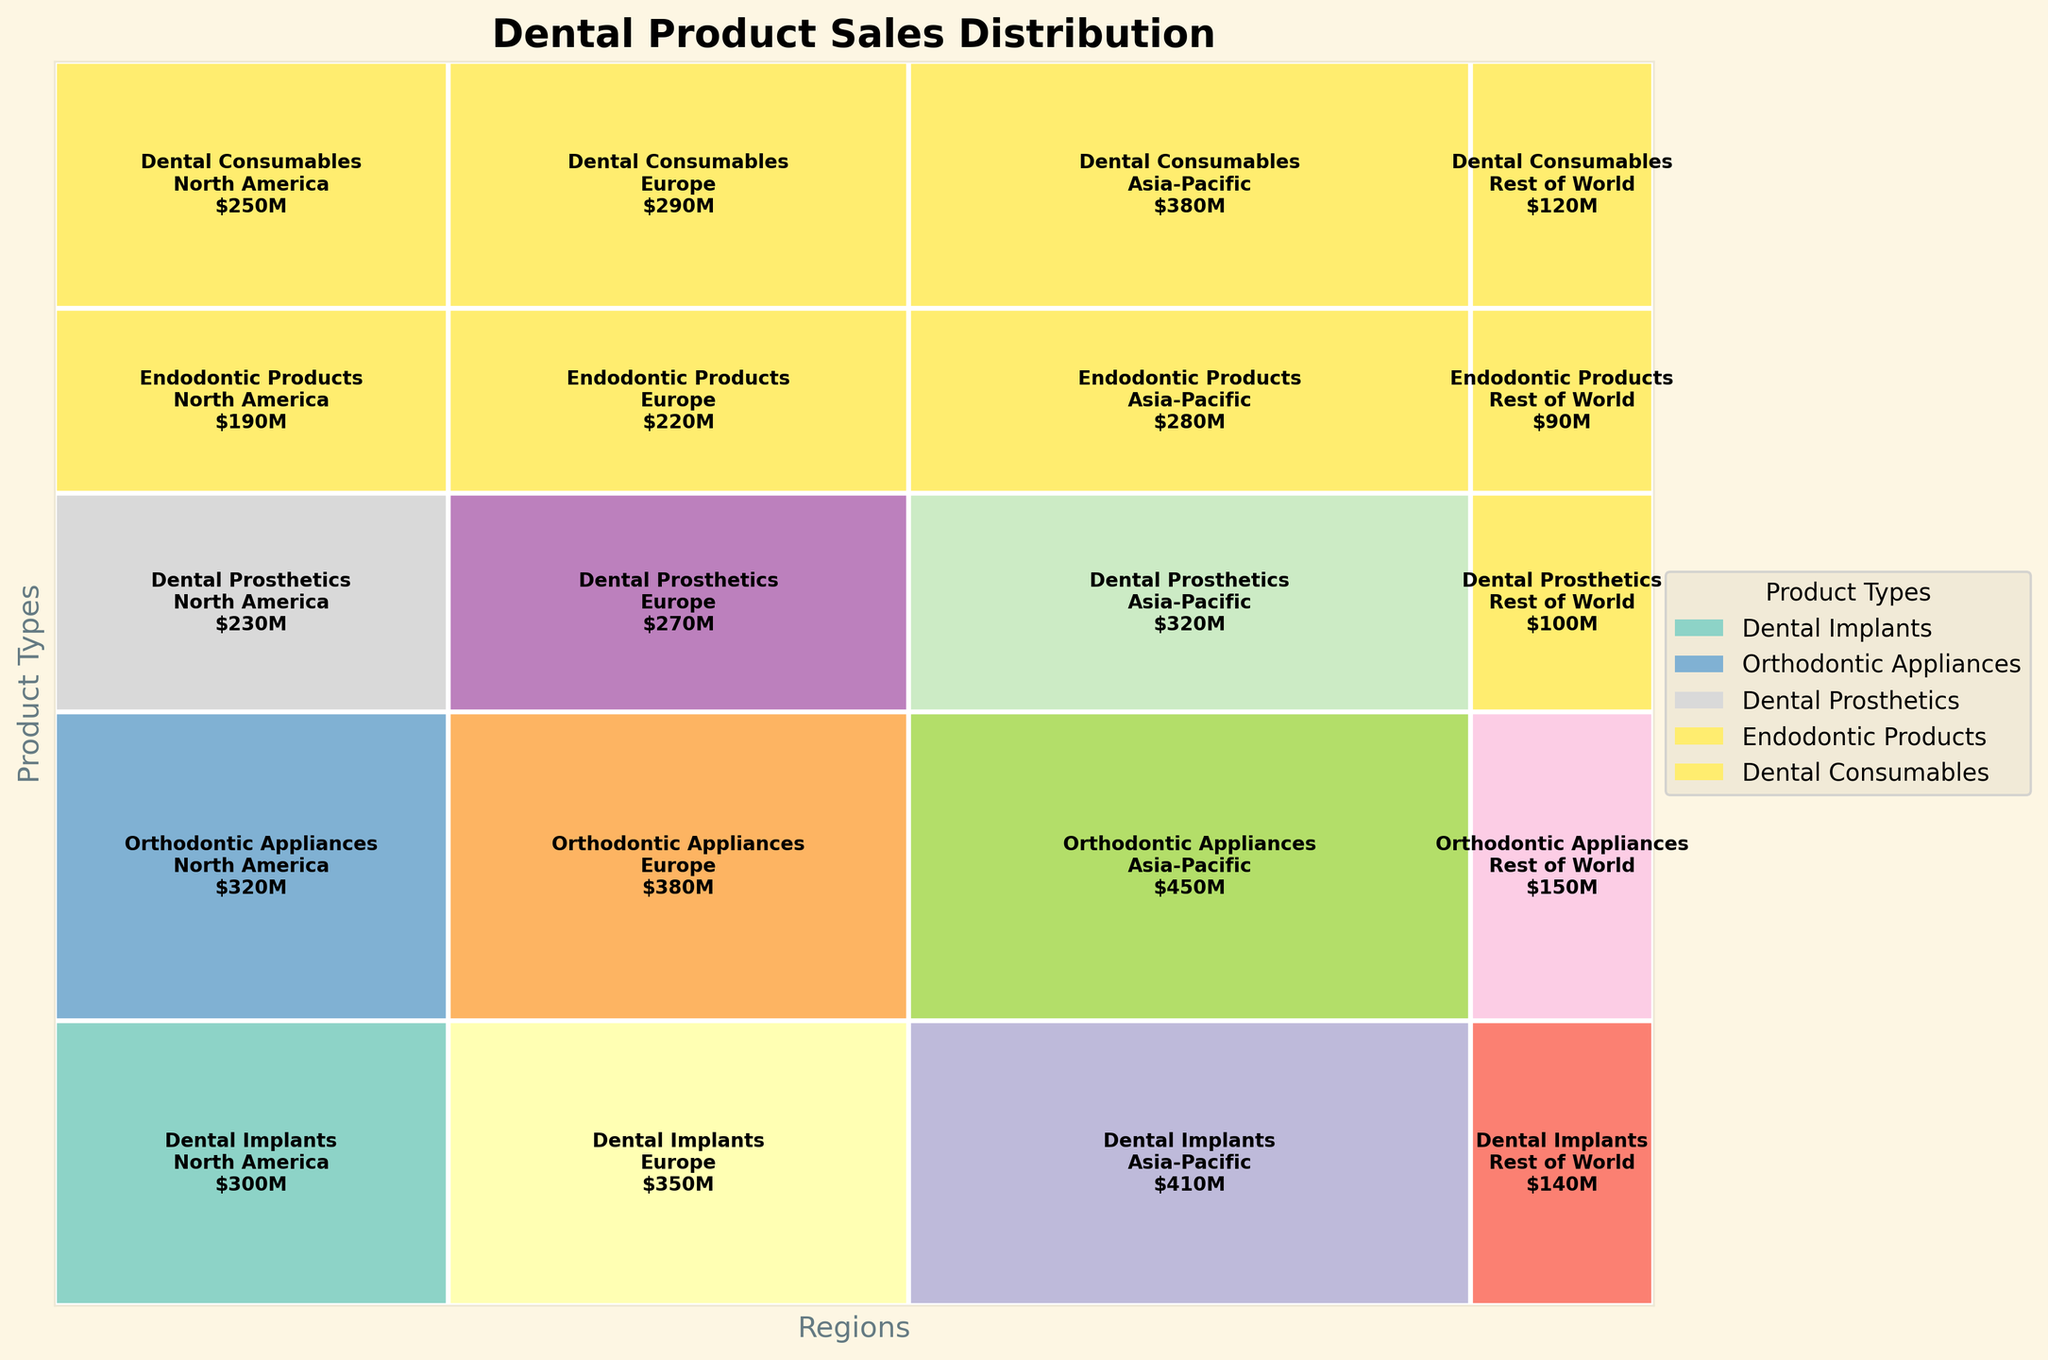What is the title of the mosaic plot? The title is located at the top of the plot in a larger font, which is used to describe the main subject of the figure. In this case, it states the overall theme or focus of the visualization.
Answer: Dental Product Sales Distribution How many product types are presented in the mosaic plot? To find this number, look at either the legend or the vertical axis labels since they categorize the main segments of the plot. Each unique label corresponds to a different product type.
Answer: 5 Which region has the highest total sales? Observe the width proportions of the plot rectangles. The region with the widest sections has the highest aggregate sales since the width is proportional to sales volume.
Answer: North America What is the total sales for Dental Implants in North America and Europe combined? Identify the rectangles corresponding to Dental Implants in both North America and Europe, and sum up their sales values. Each value is annotated within the respective rectangle.
Answer: $830M Which product type has the smallest total sales in the Rest of World region? Look for the narrowest rectangle within the Rest of World section, as the width in that region represents the total sales for each product type.
Answer: Endodontic Products Compare the sales of Dental Consumables between North America and Asia-Pacific. Which region has higher sales? Find the rectangles corresponding to Dental Consumables in both regions and compare the annotated sales values to identify the region with the higher figure.
Answer: North America What proportion of the total sales does Orthodontic Appliances represent in the Europe region? Locate the sales value for Orthodontic Appliances in Europe, then divide that by the total sales sum indicated in the visual or dataset, and convert it into a percentage.
Answer: 13.64% Which product type has the most balanced sales distribution across all regions? Identify the product type whose rectangles have the most similar widths across different regions, indicating an even distribution of sales.
Answer: Dental Consumables If you combine the sales of Dental Prosthetics and Endodontic Products in the Asia-Pacific region, what is the total? Add the individual sales values of Dental Prosthetics and Endodontic Products in Asia-Pacific, as annotated in their respective rectangles.
Answer: $420M How does the sales distribution of Orthodontic Appliances differ between North America and Rest of World? Compare the widths and annotated sales values of Orthodontic Appliances in both North America and Rest of World. This requires assessing the magnitude of difference.
Answer: North America $380M, Rest of World $120M 